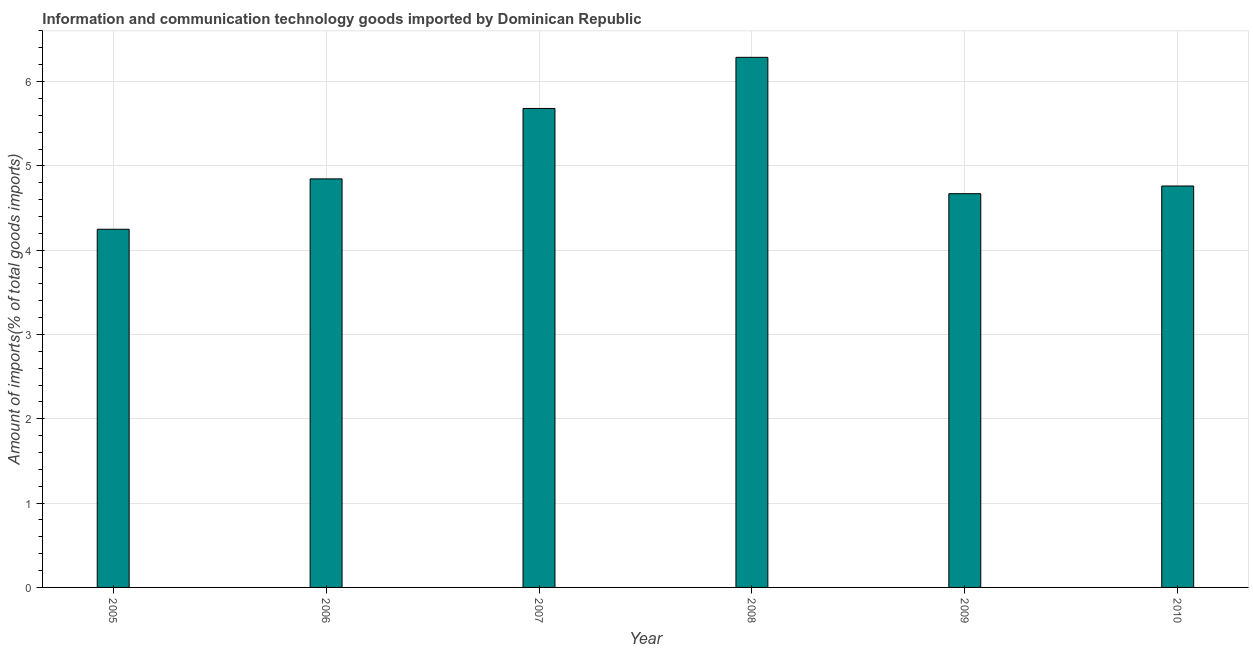Does the graph contain any zero values?
Keep it short and to the point. No. What is the title of the graph?
Offer a very short reply. Information and communication technology goods imported by Dominican Republic. What is the label or title of the X-axis?
Your response must be concise. Year. What is the label or title of the Y-axis?
Your response must be concise. Amount of imports(% of total goods imports). What is the amount of ict goods imports in 2005?
Your answer should be very brief. 4.25. Across all years, what is the maximum amount of ict goods imports?
Make the answer very short. 6.29. Across all years, what is the minimum amount of ict goods imports?
Your answer should be compact. 4.25. In which year was the amount of ict goods imports maximum?
Your response must be concise. 2008. What is the sum of the amount of ict goods imports?
Ensure brevity in your answer.  30.49. What is the difference between the amount of ict goods imports in 2008 and 2010?
Your response must be concise. 1.53. What is the average amount of ict goods imports per year?
Provide a succinct answer. 5.08. What is the median amount of ict goods imports?
Your response must be concise. 4.8. In how many years, is the amount of ict goods imports greater than 3.4 %?
Make the answer very short. 6. What is the ratio of the amount of ict goods imports in 2006 to that in 2008?
Provide a succinct answer. 0.77. Is the amount of ict goods imports in 2006 less than that in 2007?
Your answer should be compact. Yes. Is the difference between the amount of ict goods imports in 2005 and 2009 greater than the difference between any two years?
Offer a terse response. No. What is the difference between the highest and the second highest amount of ict goods imports?
Your response must be concise. 0.61. What is the difference between the highest and the lowest amount of ict goods imports?
Offer a very short reply. 2.04. How many bars are there?
Keep it short and to the point. 6. Are all the bars in the graph horizontal?
Provide a succinct answer. No. How many years are there in the graph?
Your response must be concise. 6. What is the difference between two consecutive major ticks on the Y-axis?
Offer a terse response. 1. What is the Amount of imports(% of total goods imports) of 2005?
Provide a succinct answer. 4.25. What is the Amount of imports(% of total goods imports) in 2006?
Provide a short and direct response. 4.85. What is the Amount of imports(% of total goods imports) in 2007?
Provide a short and direct response. 5.68. What is the Amount of imports(% of total goods imports) in 2008?
Keep it short and to the point. 6.29. What is the Amount of imports(% of total goods imports) of 2009?
Offer a terse response. 4.67. What is the Amount of imports(% of total goods imports) in 2010?
Keep it short and to the point. 4.76. What is the difference between the Amount of imports(% of total goods imports) in 2005 and 2006?
Make the answer very short. -0.6. What is the difference between the Amount of imports(% of total goods imports) in 2005 and 2007?
Offer a very short reply. -1.43. What is the difference between the Amount of imports(% of total goods imports) in 2005 and 2008?
Provide a succinct answer. -2.04. What is the difference between the Amount of imports(% of total goods imports) in 2005 and 2009?
Give a very brief answer. -0.42. What is the difference between the Amount of imports(% of total goods imports) in 2005 and 2010?
Offer a terse response. -0.51. What is the difference between the Amount of imports(% of total goods imports) in 2006 and 2007?
Your answer should be very brief. -0.84. What is the difference between the Amount of imports(% of total goods imports) in 2006 and 2008?
Offer a very short reply. -1.44. What is the difference between the Amount of imports(% of total goods imports) in 2006 and 2009?
Offer a very short reply. 0.18. What is the difference between the Amount of imports(% of total goods imports) in 2006 and 2010?
Your answer should be very brief. 0.08. What is the difference between the Amount of imports(% of total goods imports) in 2007 and 2008?
Your answer should be very brief. -0.61. What is the difference between the Amount of imports(% of total goods imports) in 2007 and 2009?
Make the answer very short. 1.01. What is the difference between the Amount of imports(% of total goods imports) in 2007 and 2010?
Your response must be concise. 0.92. What is the difference between the Amount of imports(% of total goods imports) in 2008 and 2009?
Your answer should be very brief. 1.62. What is the difference between the Amount of imports(% of total goods imports) in 2008 and 2010?
Your answer should be very brief. 1.53. What is the difference between the Amount of imports(% of total goods imports) in 2009 and 2010?
Give a very brief answer. -0.09. What is the ratio of the Amount of imports(% of total goods imports) in 2005 to that in 2006?
Your response must be concise. 0.88. What is the ratio of the Amount of imports(% of total goods imports) in 2005 to that in 2007?
Provide a short and direct response. 0.75. What is the ratio of the Amount of imports(% of total goods imports) in 2005 to that in 2008?
Your response must be concise. 0.68. What is the ratio of the Amount of imports(% of total goods imports) in 2005 to that in 2009?
Offer a terse response. 0.91. What is the ratio of the Amount of imports(% of total goods imports) in 2005 to that in 2010?
Provide a succinct answer. 0.89. What is the ratio of the Amount of imports(% of total goods imports) in 2006 to that in 2007?
Offer a very short reply. 0.85. What is the ratio of the Amount of imports(% of total goods imports) in 2006 to that in 2008?
Keep it short and to the point. 0.77. What is the ratio of the Amount of imports(% of total goods imports) in 2006 to that in 2009?
Give a very brief answer. 1.04. What is the ratio of the Amount of imports(% of total goods imports) in 2006 to that in 2010?
Keep it short and to the point. 1.02. What is the ratio of the Amount of imports(% of total goods imports) in 2007 to that in 2008?
Provide a succinct answer. 0.9. What is the ratio of the Amount of imports(% of total goods imports) in 2007 to that in 2009?
Your answer should be very brief. 1.22. What is the ratio of the Amount of imports(% of total goods imports) in 2007 to that in 2010?
Keep it short and to the point. 1.19. What is the ratio of the Amount of imports(% of total goods imports) in 2008 to that in 2009?
Your response must be concise. 1.35. What is the ratio of the Amount of imports(% of total goods imports) in 2008 to that in 2010?
Provide a succinct answer. 1.32. What is the ratio of the Amount of imports(% of total goods imports) in 2009 to that in 2010?
Make the answer very short. 0.98. 